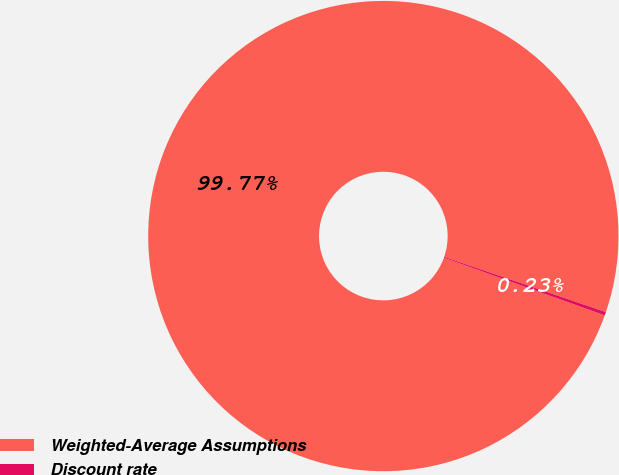<chart> <loc_0><loc_0><loc_500><loc_500><pie_chart><fcel>Weighted-Average Assumptions<fcel>Discount rate<nl><fcel>99.77%<fcel>0.23%<nl></chart> 